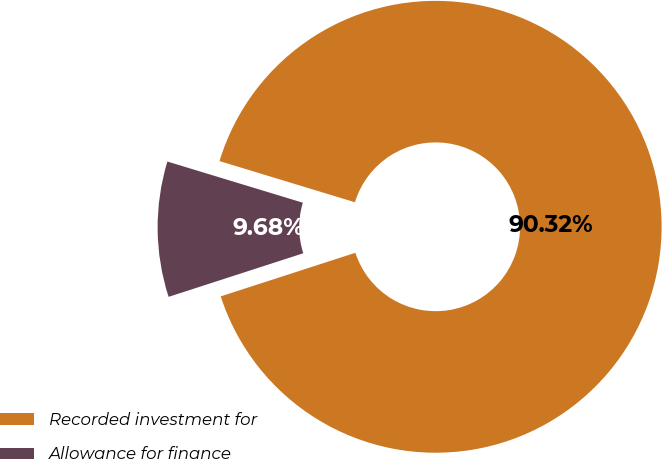Convert chart. <chart><loc_0><loc_0><loc_500><loc_500><pie_chart><fcel>Recorded investment for<fcel>Allowance for finance<nl><fcel>90.32%<fcel>9.68%<nl></chart> 